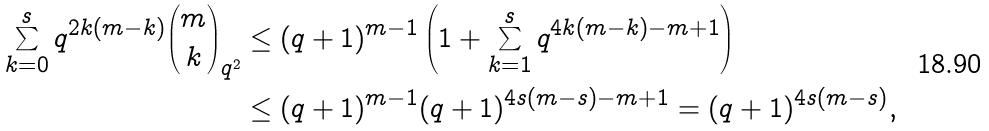<formula> <loc_0><loc_0><loc_500><loc_500>\sum _ { k = 0 } ^ { s } q ^ { 2 k ( m - k ) } \binom { m } { k } _ { q ^ { 2 } } & \leq ( q + 1 ) ^ { m - 1 } \left ( 1 + \sum _ { k = 1 } ^ { s } q ^ { 4 k ( m - k ) - m + 1 } \right ) \\ & \leq ( q + 1 ) ^ { m - 1 } ( q + 1 ) ^ { 4 s ( m - s ) - m + 1 } = ( q + 1 ) ^ { 4 s ( m - s ) } ,</formula> 